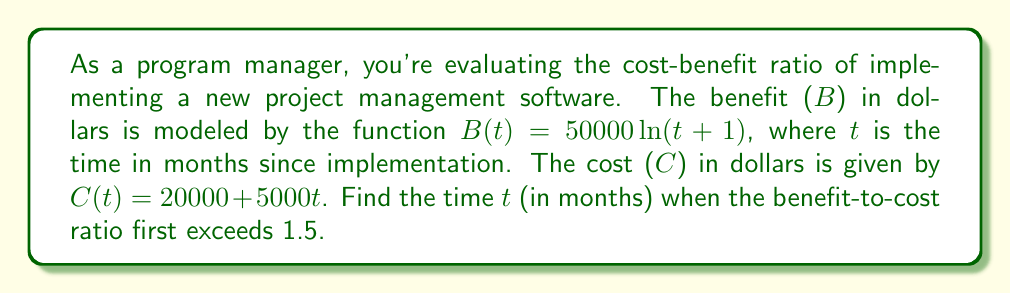Solve this math problem. To solve this problem, we need to follow these steps:

1) The benefit-to-cost ratio is given by $\frac{B(t)}{C(t)}$. We want to find when this ratio exceeds 1.5.

2) Set up the inequality:

   $$\frac{B(t)}{C(t)} > 1.5$$

3) Substitute the given functions:

   $$\frac{50000 \ln(t+1)}{20000 + 5000t} > 1.5$$

4) Multiply both sides by $(20000 + 5000t)$:

   $$50000 \ln(t+1) > 1.5(20000 + 5000t)$$

5) Simplify the right side:

   $$50000 \ln(t+1) > 30000 + 7500t$$

6) Divide both sides by 50000:

   $$\ln(t+1) > 0.6 + 0.15t$$

7) Apply $e^x$ to both sides:

   $$t+1 > e^{0.6 + 0.15t}$$

8) Subtract 1 from both sides:

   $$t > e^{0.6 + 0.15t} - 1$$

This equation cannot be solved algebraically. We need to use numerical methods or graphing to find the solution. By plotting both sides of the inequality, we can see that they intersect at approximately t = 4.6 months.
Answer: The benefit-to-cost ratio first exceeds 1.5 after approximately 4.6 months. 